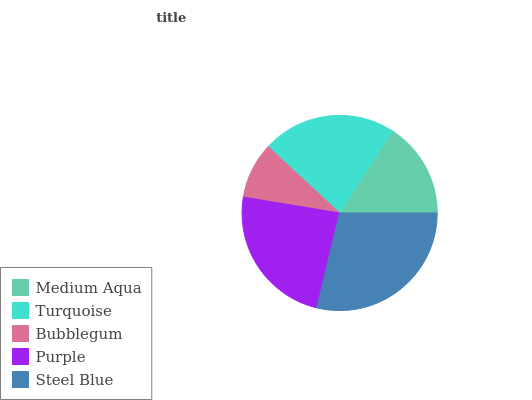Is Bubblegum the minimum?
Answer yes or no. Yes. Is Steel Blue the maximum?
Answer yes or no. Yes. Is Turquoise the minimum?
Answer yes or no. No. Is Turquoise the maximum?
Answer yes or no. No. Is Turquoise greater than Medium Aqua?
Answer yes or no. Yes. Is Medium Aqua less than Turquoise?
Answer yes or no. Yes. Is Medium Aqua greater than Turquoise?
Answer yes or no. No. Is Turquoise less than Medium Aqua?
Answer yes or no. No. Is Turquoise the high median?
Answer yes or no. Yes. Is Turquoise the low median?
Answer yes or no. Yes. Is Steel Blue the high median?
Answer yes or no. No. Is Bubblegum the low median?
Answer yes or no. No. 